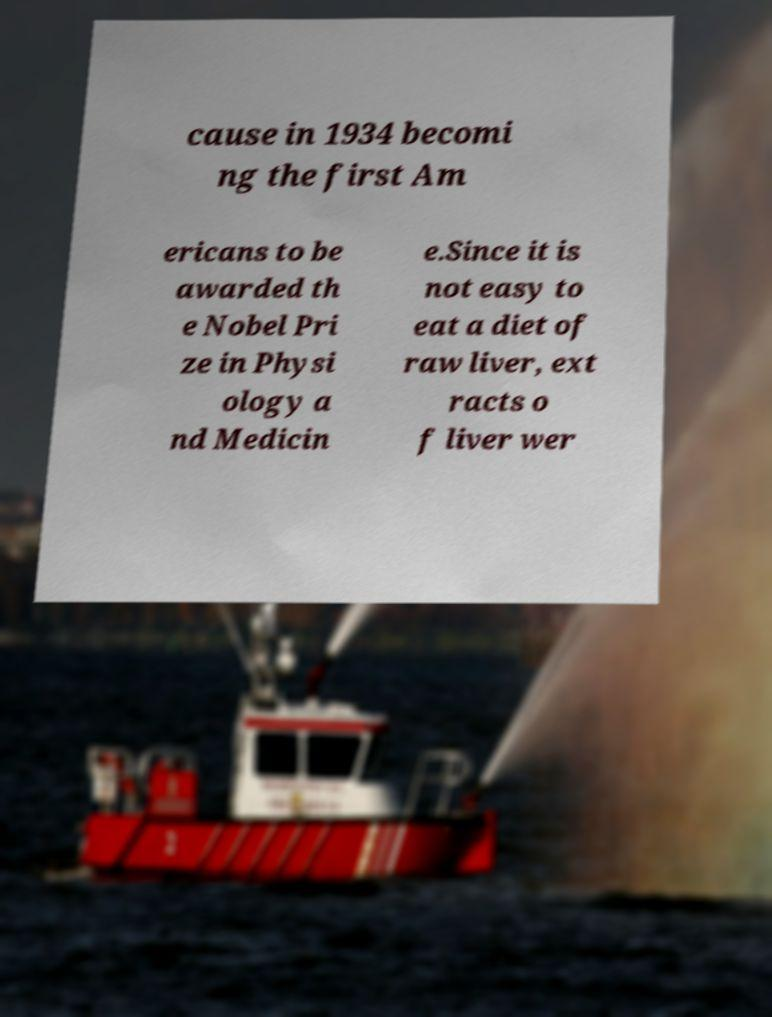For documentation purposes, I need the text within this image transcribed. Could you provide that? cause in 1934 becomi ng the first Am ericans to be awarded th e Nobel Pri ze in Physi ology a nd Medicin e.Since it is not easy to eat a diet of raw liver, ext racts o f liver wer 